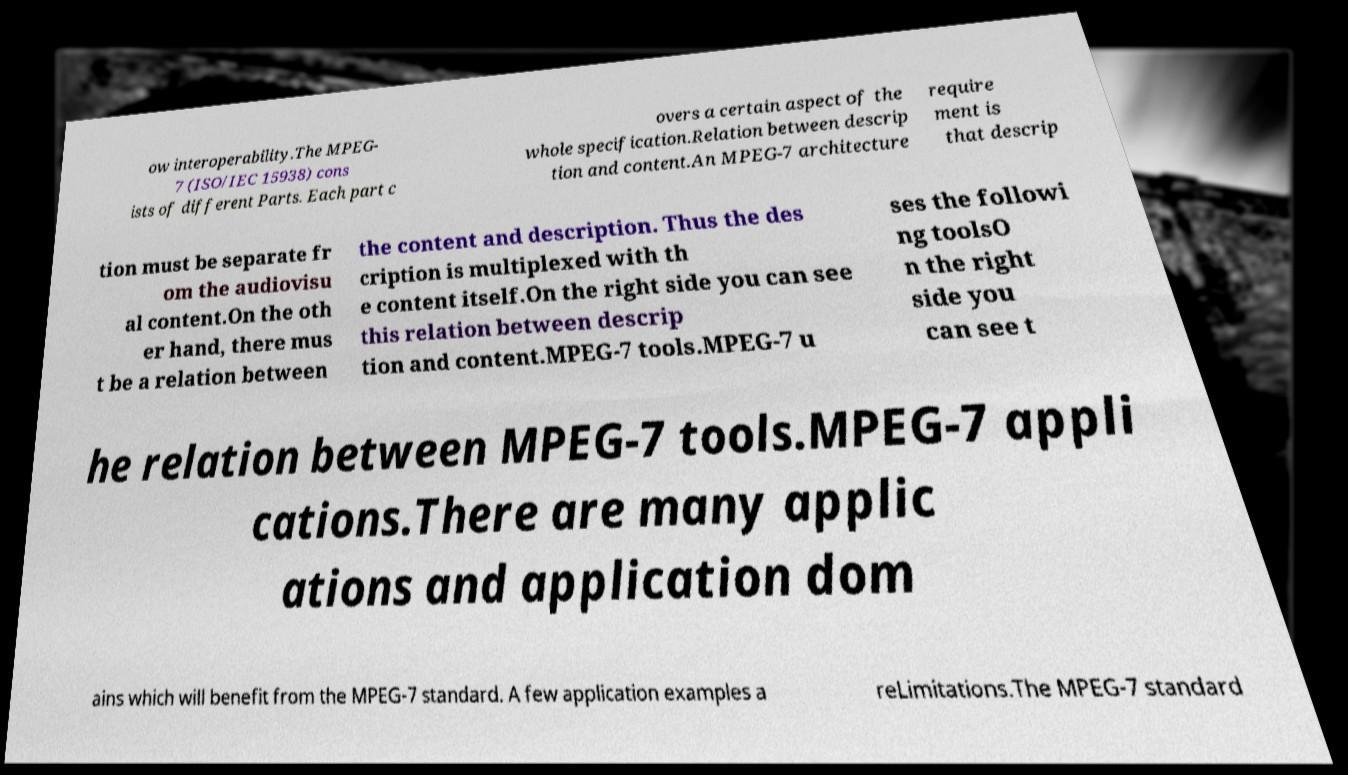Could you assist in decoding the text presented in this image and type it out clearly? ow interoperability.The MPEG- 7 (ISO/IEC 15938) cons ists of different Parts. Each part c overs a certain aspect of the whole specification.Relation between descrip tion and content.An MPEG-7 architecture require ment is that descrip tion must be separate fr om the audiovisu al content.On the oth er hand, there mus t be a relation between the content and description. Thus the des cription is multiplexed with th e content itself.On the right side you can see this relation between descrip tion and content.MPEG-7 tools.MPEG-7 u ses the followi ng toolsO n the right side you can see t he relation between MPEG-7 tools.MPEG-7 appli cations.There are many applic ations and application dom ains which will benefit from the MPEG-7 standard. A few application examples a reLimitations.The MPEG-7 standard 